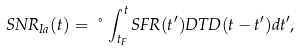Convert formula to latex. <formula><loc_0><loc_0><loc_500><loc_500>S N R _ { I a } ( t ) = \nu \int _ { t _ { F } } ^ { t } S F R ( t ^ { \prime } ) D T D ( t - t ^ { \prime } ) d t ^ { \prime } ,</formula> 